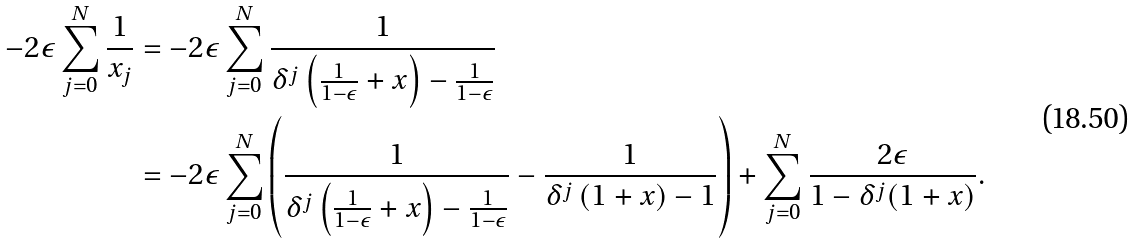Convert formula to latex. <formula><loc_0><loc_0><loc_500><loc_500>- 2 \epsilon \sum _ { j = 0 } ^ { N } \frac { 1 } { x _ { j } } & = - 2 \epsilon \sum _ { j = 0 } ^ { N } \frac { 1 } { \delta ^ { j } \left ( \frac { 1 } { 1 - \epsilon } + x \right ) - \frac { 1 } { 1 - \epsilon } } \\ & = - 2 \epsilon \sum _ { j = 0 } ^ { N } \left ( \frac { 1 } { \delta ^ { j } \left ( \frac { 1 } { 1 - \epsilon } + x \right ) - \frac { 1 } { 1 - \epsilon } } - \frac { 1 } { \delta ^ { j } \left ( 1 + x \right ) - 1 } \right ) + \sum _ { j = 0 } ^ { N } \frac { 2 \epsilon } { 1 - \delta ^ { j } ( 1 + x ) } .</formula> 